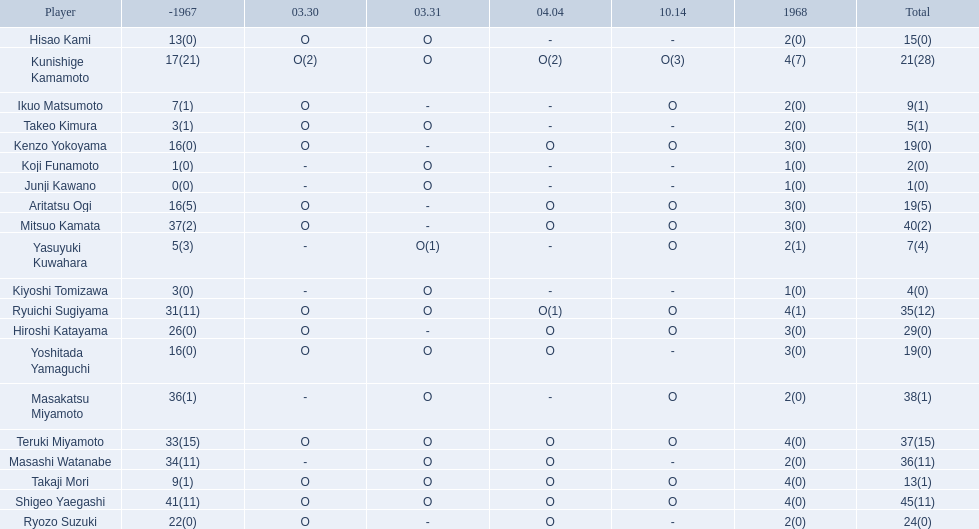Who are all of the players? Shigeo Yaegashi, Mitsuo Kamata, Masakatsu Miyamoto, Masashi Watanabe, Teruki Miyamoto, Ryuichi Sugiyama, Hiroshi Katayama, Ryozo Suzuki, Kunishige Kamamoto, Aritatsu Ogi, Yoshitada Yamaguchi, Kenzo Yokoyama, Hisao Kami, Takaji Mori, Ikuo Matsumoto, Yasuyuki Kuwahara, Takeo Kimura, Kiyoshi Tomizawa, Koji Funamoto, Junji Kawano. How many points did they receive? 45(11), 40(2), 38(1), 36(11), 37(15), 35(12), 29(0), 24(0), 21(28), 19(5), 19(0), 19(0), 15(0), 13(1), 9(1), 7(4), 5(1), 4(0), 2(0), 1(0). What about just takaji mori and junji kawano? 13(1), 1(0). Of the two, who had more points? Takaji Mori. 